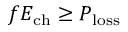<formula> <loc_0><loc_0><loc_500><loc_500>f E _ { c h } \geq P _ { l o s s }</formula> 